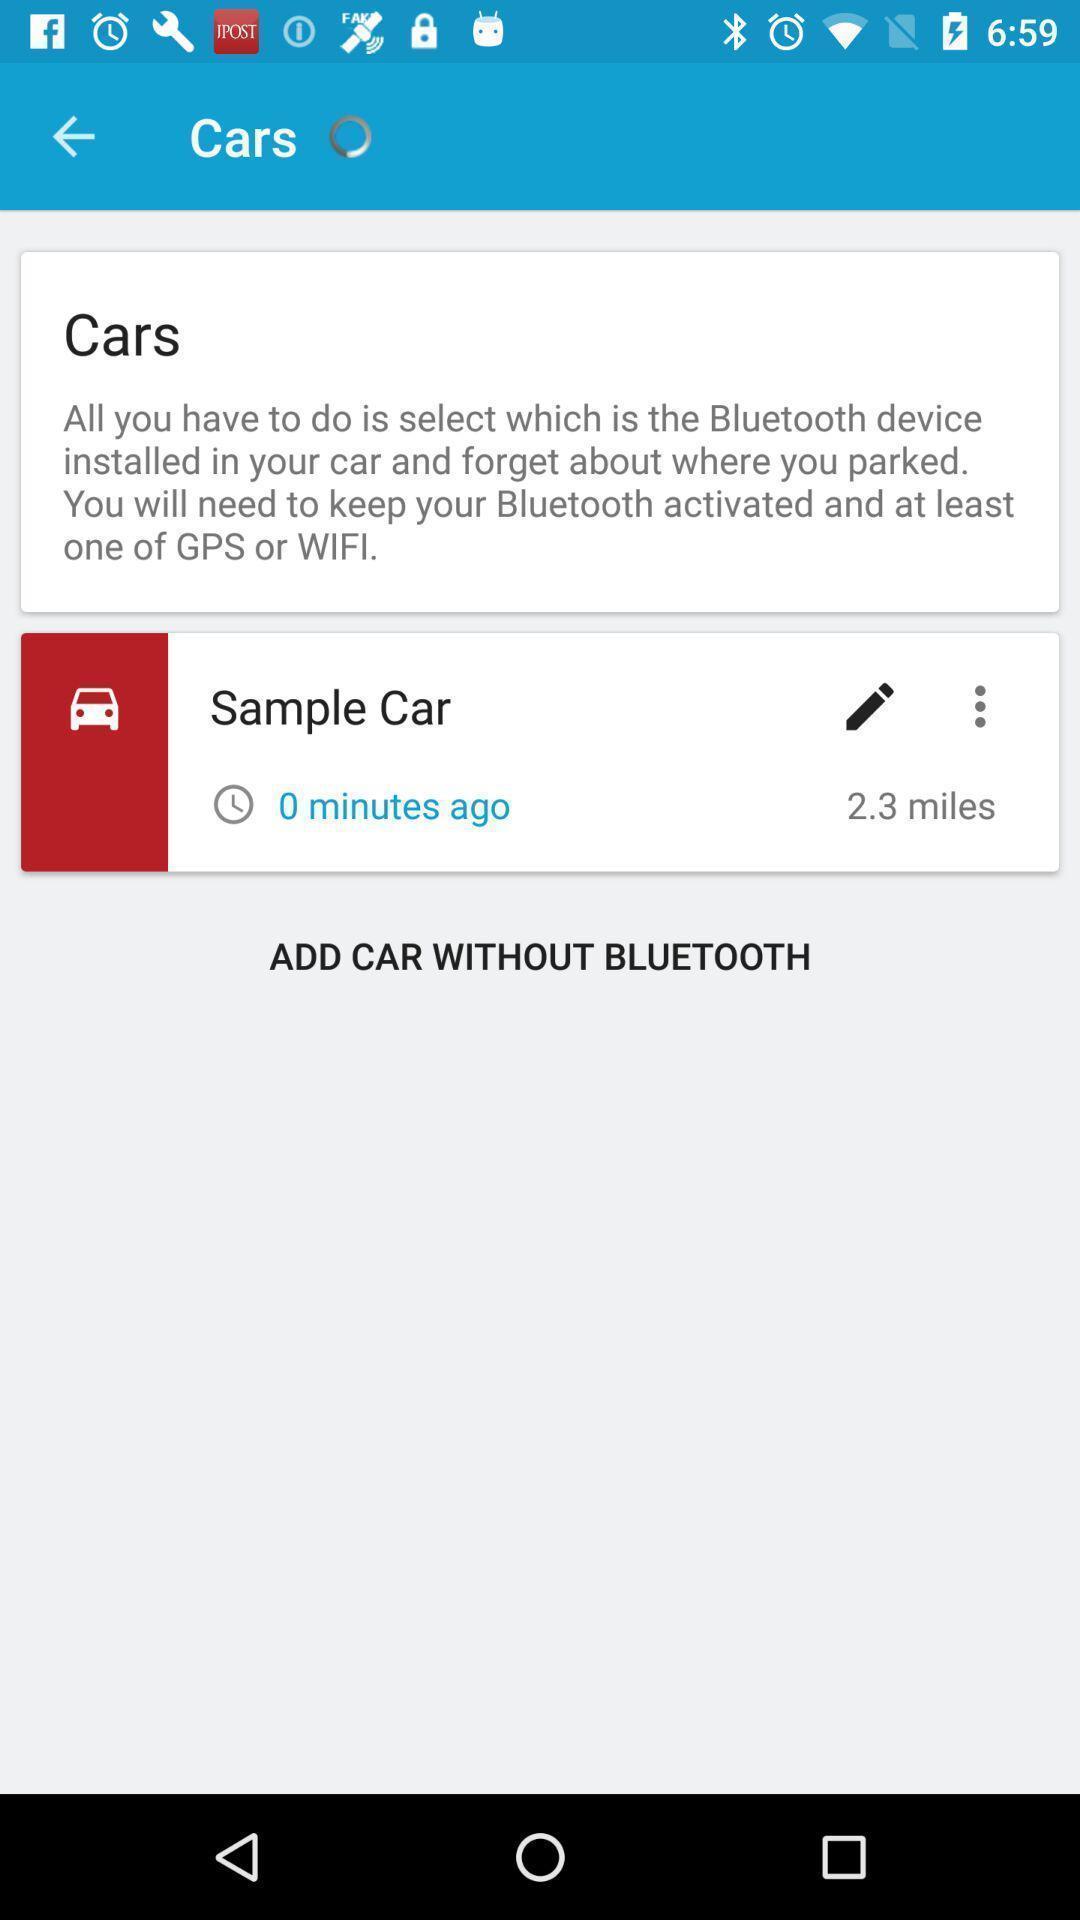What is the overall content of this screenshot? Page showing information about parking car. 